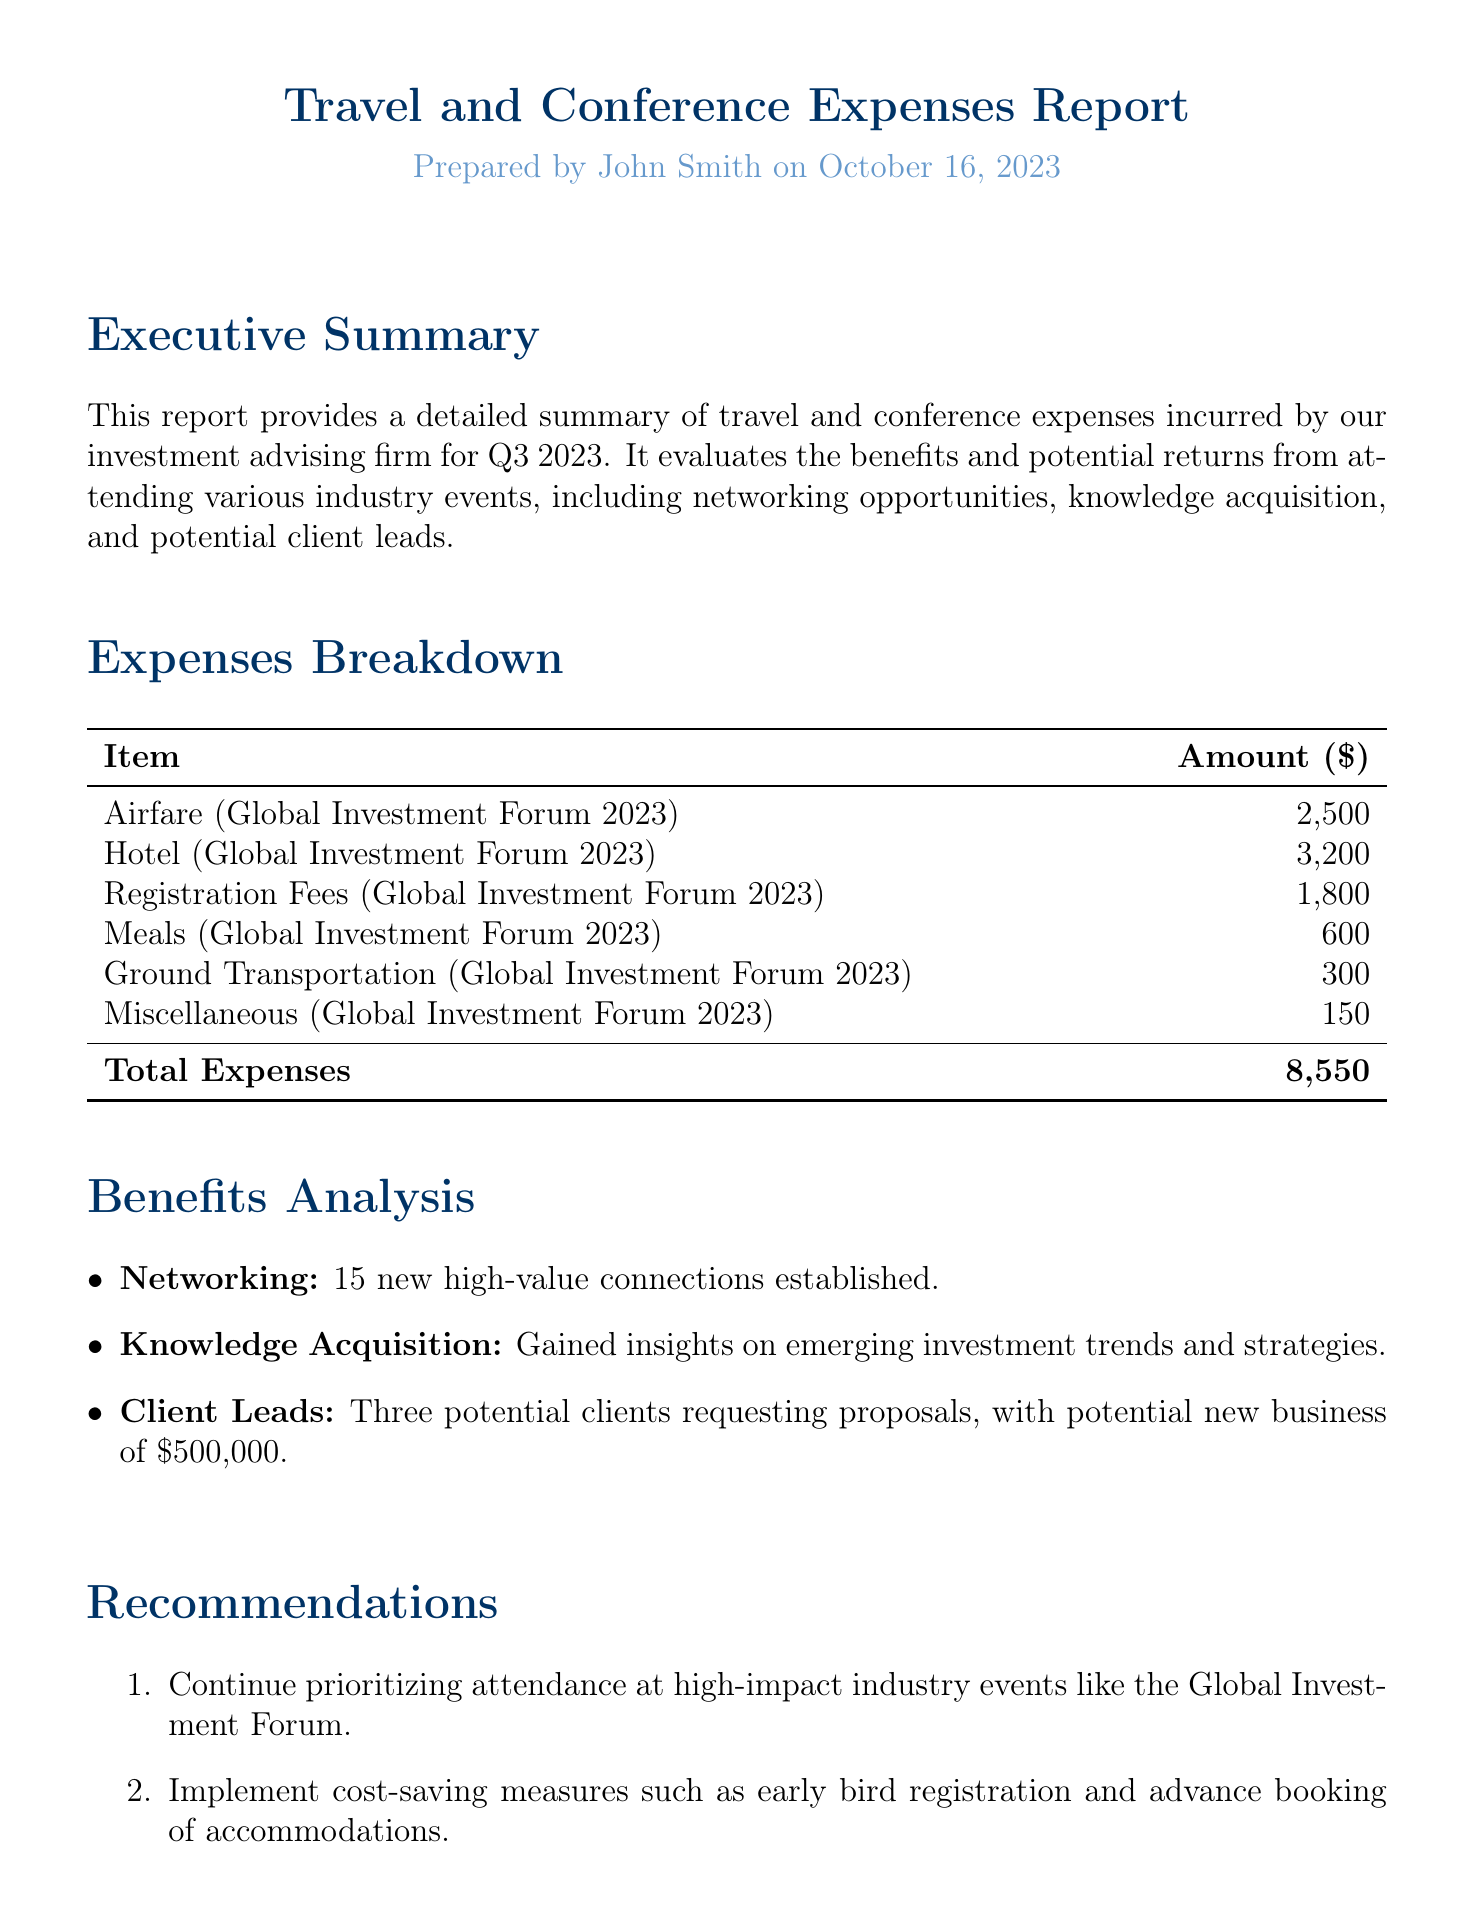What was the total expense incurred for the conference? The total expense is provided at the bottom of the expenses breakdown table.
Answer: 8,550 How many new high-value connections were established? The number of connections established is mentioned in the benefits analysis section.
Answer: 15 What were the registration fees for the Global Investment Forum? The registration fees are listed in the expenses breakdown table.
Answer: 1,800 What potential new business amount is associated with client leads? The potential new business amount is stated in the benefits analysis section.
Answer: 500,000 What date was this report prepared? The preparation date is included in the header of the document.
Answer: October 16, 2023 What is one recommendation given in the report? The recommendations are listed in a numbered format under the recommendations section.
Answer: Continue prioritizing attendance at high-impact industry events What type of event was the Global Investment Forum described as? The Global Investment Forum is referenced in the executive summary and expenses section.
Answer: High-impact industry event What was the cost for meals during the conference? The meals expense is specified in the expenses breakdown table.
Answer: 600 